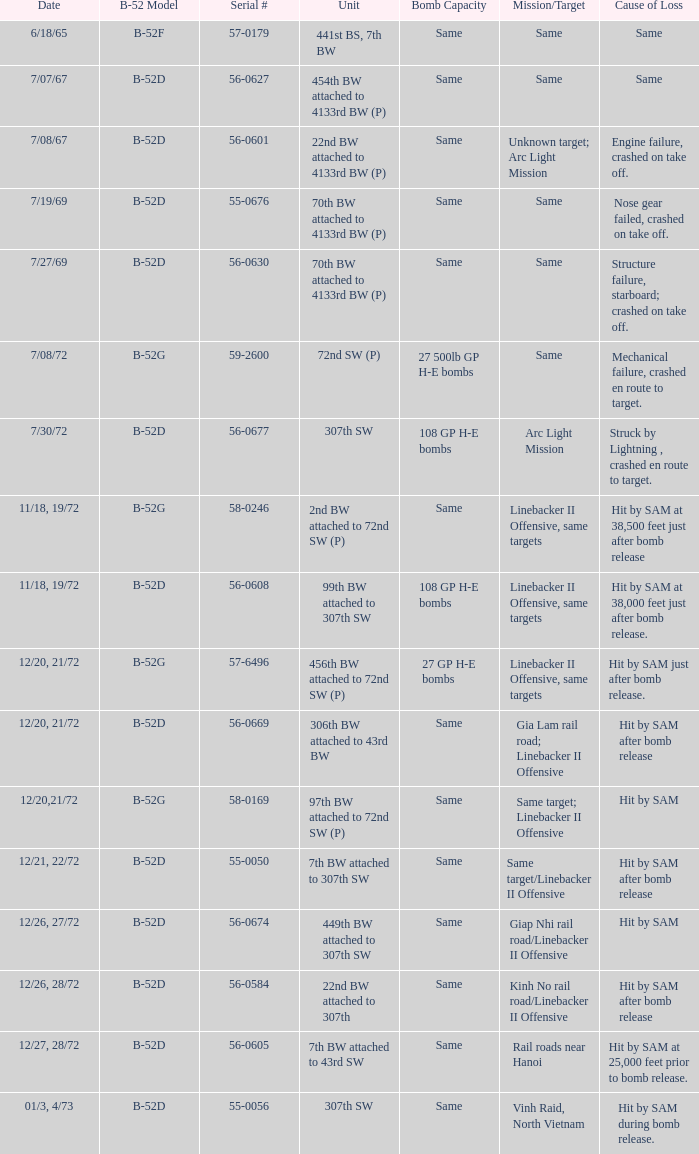When 7th bombardment wing linked to 43rd strategic wing is the unit, what is the b-52 variant? B-52D. 